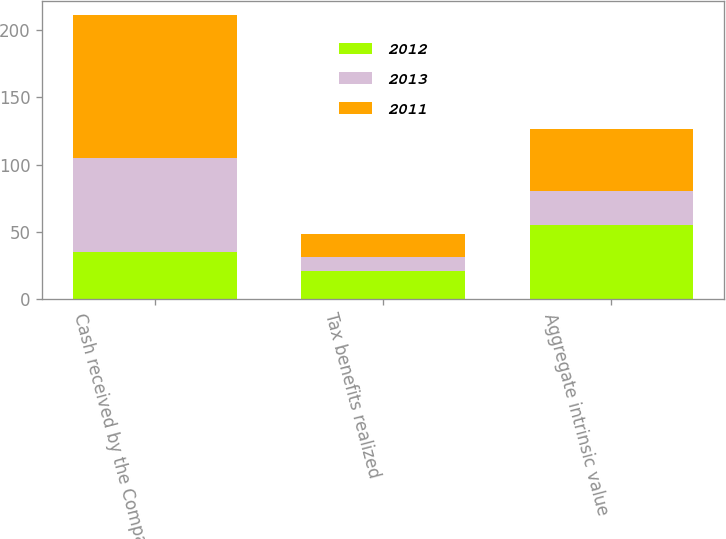<chart> <loc_0><loc_0><loc_500><loc_500><stacked_bar_chart><ecel><fcel>Cash received by the Company<fcel>Tax benefits realized<fcel>Aggregate intrinsic value<nl><fcel>2012<fcel>35.4<fcel>21.3<fcel>55.4<nl><fcel>2013<fcel>69.4<fcel>9.7<fcel>25.3<nl><fcel>2011<fcel>106.1<fcel>17.7<fcel>45.5<nl></chart> 